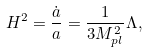<formula> <loc_0><loc_0><loc_500><loc_500>H ^ { 2 } = \frac { \dot { a } } { a } = \frac { 1 } { 3 M _ { p l } ^ { 2 } } \Lambda ,</formula> 